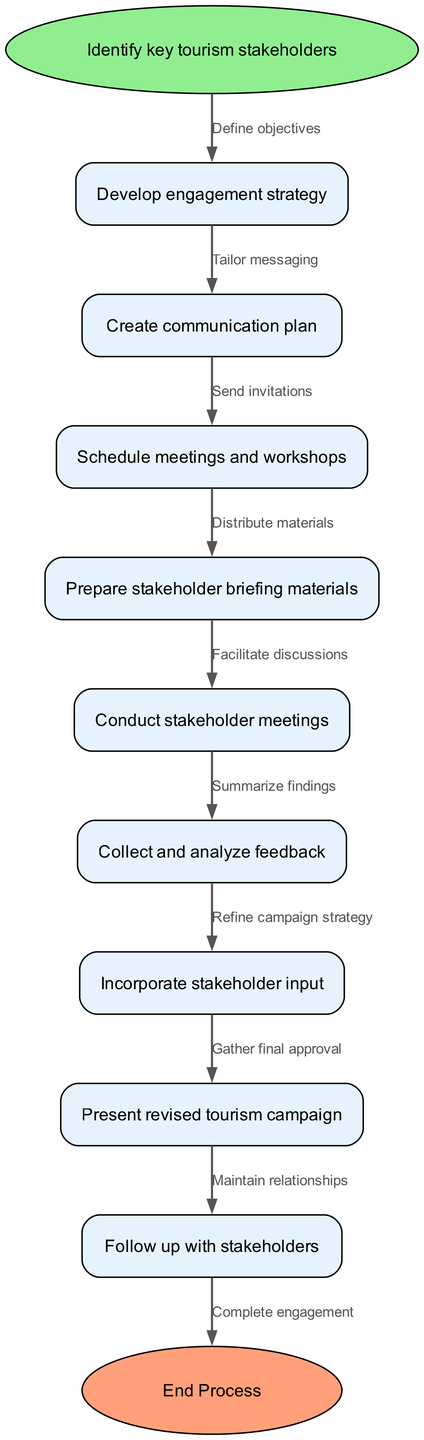What is the starting node of the process? The diagram begins with a node labeled "Identify key tourism stakeholders," which is indicated as the starting point or entry into the flow chart.
Answer: Identify key tourism stakeholders How many nodes are present in the diagram? Counting from the starting node through all other nodes listed, there are 9 distinct nodes in total, including both the start and end nodes.
Answer: 9 Which node follows "Develop engagement strategy"? The diagram indicates that "Create communication plan" directly follows the node "Develop engagement strategy," signifying the sequential flow of the process.
Answer: Create communication plan What is the last node in the process? The flow chart concludes with the "End Process" node, which is clearly marked as the final step in the engagement process.
Answer: End Process What is the edge that connects "Conduct stakeholder meetings" to the next node? The edge connecting "Conduct stakeholder meetings" to "Collect and analyze feedback" is labeled "Summarize findings," which describes the action taken to transition to the next step.
Answer: Summarize findings Which node is connected to the starting node? The first node that connects to the starting node "Identify key tourism stakeholders" is "Develop engagement strategy," showing the initial step that follows after identifying stakeholders.
Answer: Develop engagement strategy What is the primary goal of the process illustrated in the diagram? The main objective of the diagram is to depict the steps involved in organizing a tourism stakeholder engagement process, including various related actions and feedback incorporation.
Answer: Organizing tourism stakeholder engagement How many edges are used in the diagram? There is a total of 8 edges connecting the nodes, which describe the transitions between different steps in the tourism stakeholder engagement process.
Answer: 8 What is the purpose of the edge labeled "Gather final approval"? This edge signifies the process of acquiring final consent or agreement from stakeholders after presenting the revised tourism campaign, highlighting a key decision point in the engagement process.
Answer: Gather final approval 